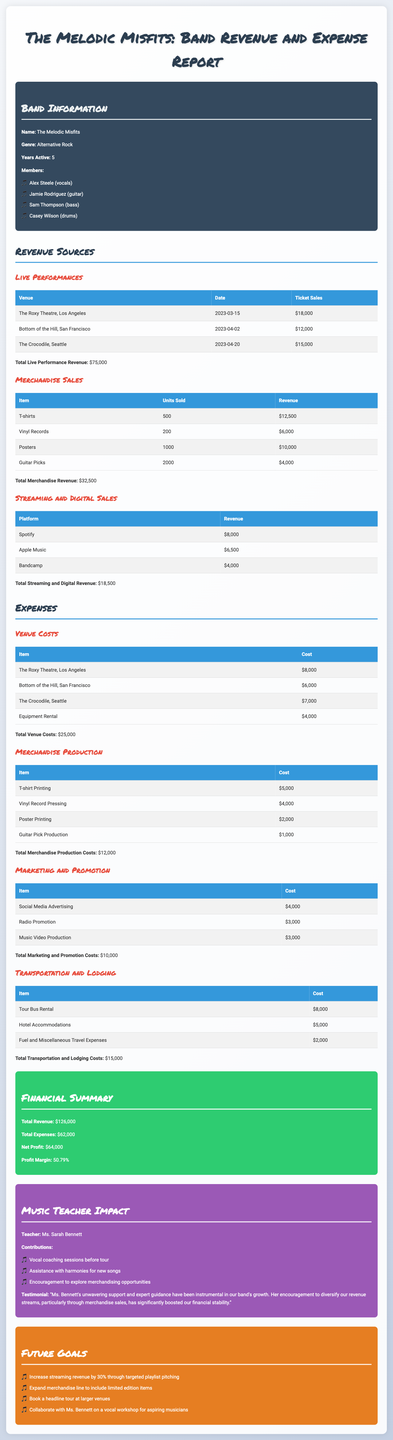what is the total revenue? The total revenue is the sum of all revenue sources in the document including live performances, merchandise sales, and streaming, totaling $75000 + $32500 + $18500.
Answer: $126000 what was the revenue from merchandise sales? The revenue from merchandise sales can be found in the breakdown section for merchandise sales, which shows a total amount of $32500.
Answer: $32500 how much did The Roxy Theatre cost? The cost for The Roxy Theatre is listed in the venue costs breakdown, specifically showing a cost of $8000.
Answer: $8000 who provided vocal coaching sessions? The music teacher's impact section highlights Ms. Sarah Bennett's contributions including vocal coaching sessions.
Answer: Ms. Sarah Bennett what is the net profit? The net profit is calculated as total revenue minus total expenses, which is $126000 - $62000.
Answer: $64000 how many T-shirts were sold? The merchandise sales breakdown indicates that 500 T-shirts were sold during the revenue period.
Answer: 500 what percentage increase in streaming revenue is targeted? The future goals section mentions a target to increase streaming revenue by 30%.
Answer: 30% which item had the highest revenue in merchandise sales? In the merchandise sales breakdown, the highest revenue item is T-shirts with a revenue of $12500.
Answer: T-shirts how many members are in the band? The band information section lists four members, reflecting the total number of band members.
Answer: 4 